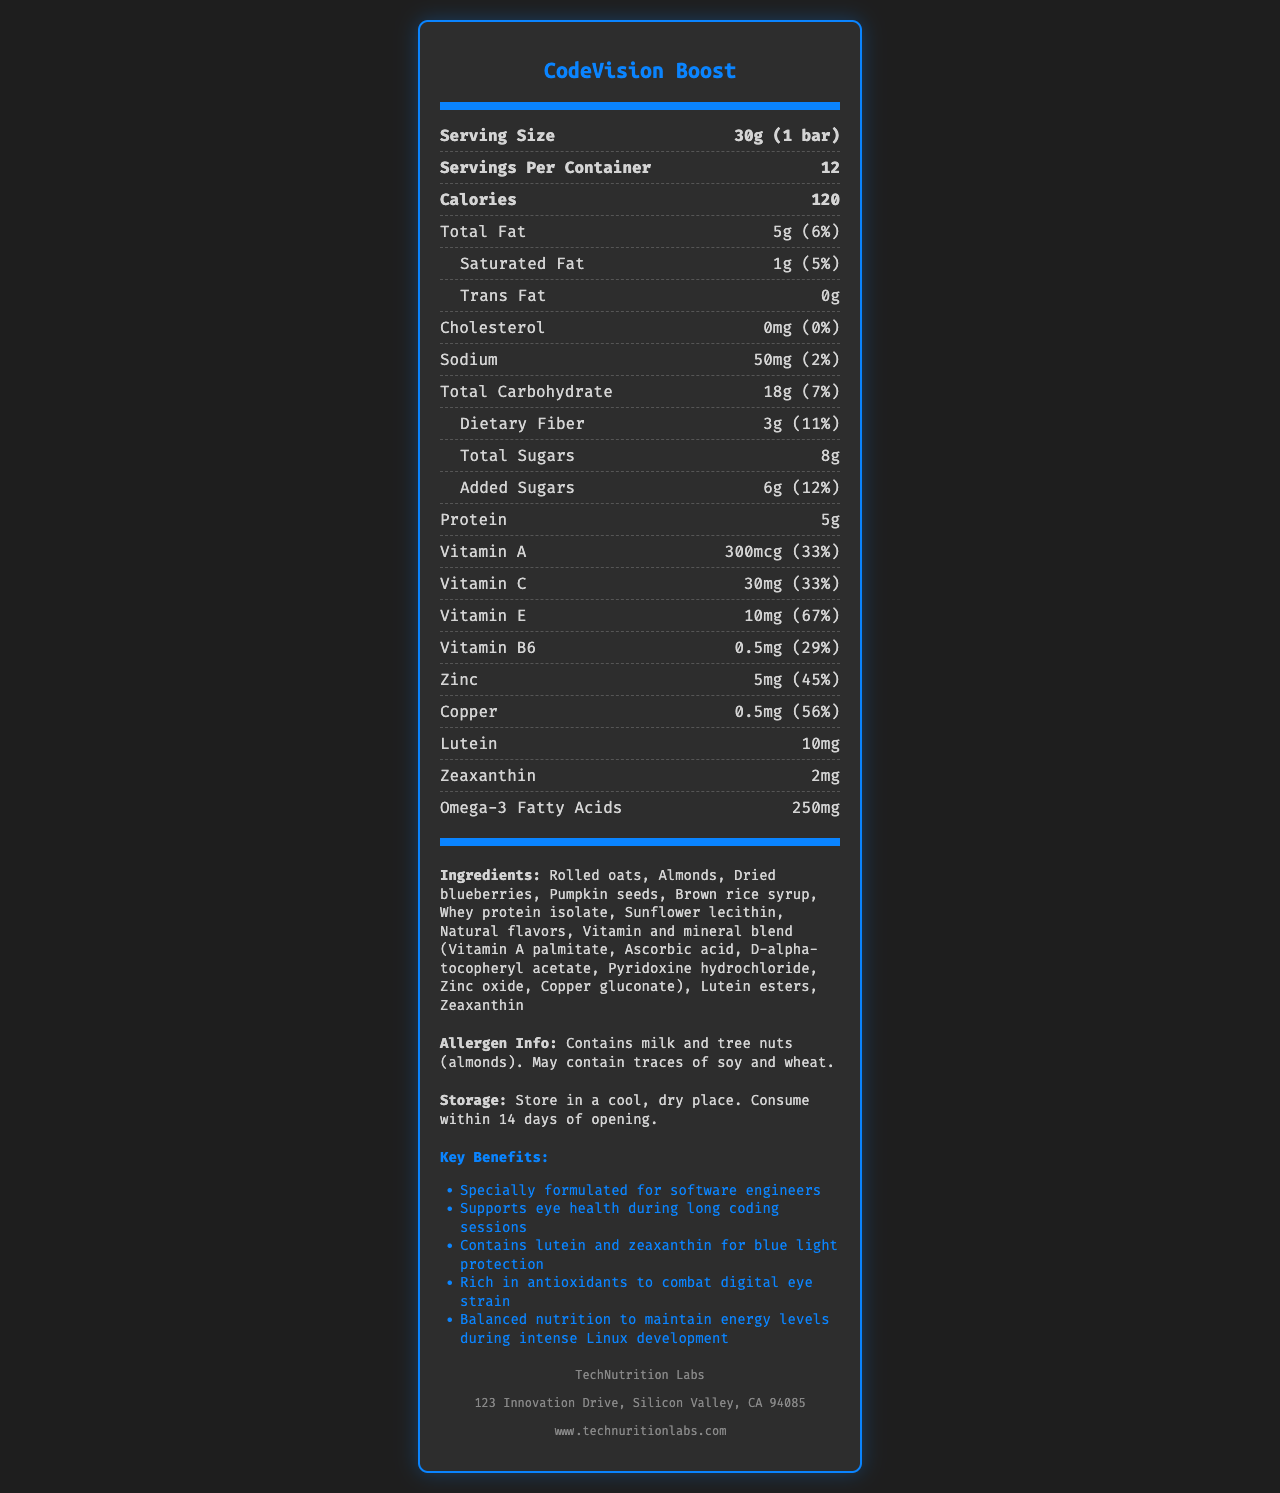what is the serving size for CodeVision Boost? The serving size is explicitly mentioned as "30g (1 bar)" in the document.
Answer: 30g (1 bar) how many calories are there per serving? The document states that there are 120 calories per serving.
Answer: 120 calories what is the total fat content per serving? The total fat content per serving is listed as "5g" in the nutrition facts.
Answer: 5g how much dietary fiber does each serving provide? The document specifies that each serving provides "3g" of dietary fiber.
Answer: 3g what percentage of the daily value of Vitamin A is included in one serving? The document indicates that one serving contains 33% of the daily value of Vitamin A.
Answer: 33% what is the recommended storage method for CodeVision Boost? The storage instructions in the document recommend storing the product in a cool, dry place and consuming it within 14 days of opening.
Answer: Store in a cool, dry place. Consume within 14 days of opening. which ingredient is not present in CodeVision Boost? A. Almonds B. Peanuts C. Dried blueberries The listed ingredients include almonds and dried blueberries, but not peanuts.
Answer: B. Peanuts which of the following vitamins is included in CodeVision Boost at the highest percentage of the daily value? A. Vitamin A B. Vitamin C C. Vitamin E D. Vitamin B6 Vitamin E is included at 67% of the daily value, which is higher than the other listed vitamins.
Answer: C. Vitamin E does CodeVision Boost contain any trans fat? The document specifies that the trans fat content is "0g".
Answer: No does the product have any allergens? The document states that it contains milk and tree nuts (almonds), and may contain traces of soy and wheat.
Answer: Yes summarize the main benefits of CodeVision Boost. The document summarizes the key benefits such as supporting eye health, providing antioxidants, and balanced nutrition which are aimed at software engineers.
Answer: CodeVision Boost is a vitamin-fortified snack designed for software engineers. It supports eye health during long coding sessions and is rich in antioxidants to combat digital eye strain. It provides balanced nutrition to maintain energy levels. how many grams of Omega-3 Fatty Acids are in one serving? The document provides the amount of Omega-3 Fatty Acids in milligrams (250mg), but not in grams directly. To convert it to grams, one would need to know the conversion (1g = 1000mg), which was not explicitly provided in the document for this context.
Answer: Cannot be determined 